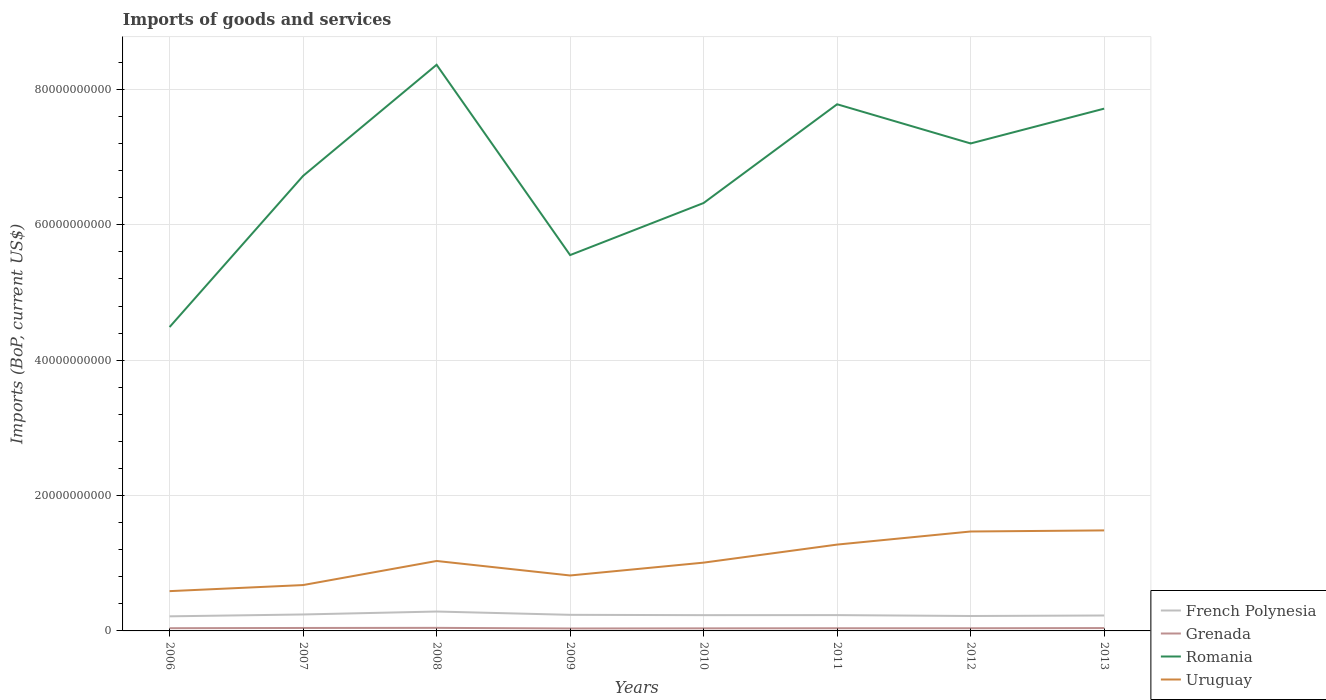How many different coloured lines are there?
Ensure brevity in your answer.  4. Does the line corresponding to Grenada intersect with the line corresponding to Romania?
Offer a very short reply. No. Across all years, what is the maximum amount spent on imports in Romania?
Offer a terse response. 4.49e+1. What is the total amount spent on imports in Grenada in the graph?
Your response must be concise. 4.14e+07. What is the difference between the highest and the second highest amount spent on imports in Romania?
Your response must be concise. 3.87e+1. What is the difference between the highest and the lowest amount spent on imports in French Polynesia?
Provide a short and direct response. 3. Is the amount spent on imports in Grenada strictly greater than the amount spent on imports in Uruguay over the years?
Keep it short and to the point. Yes. How many lines are there?
Your answer should be compact. 4. What is the difference between two consecutive major ticks on the Y-axis?
Give a very brief answer. 2.00e+1. Are the values on the major ticks of Y-axis written in scientific E-notation?
Your answer should be very brief. No. Does the graph contain grids?
Your answer should be very brief. Yes. How many legend labels are there?
Provide a succinct answer. 4. What is the title of the graph?
Your response must be concise. Imports of goods and services. Does "Senegal" appear as one of the legend labels in the graph?
Your answer should be very brief. No. What is the label or title of the X-axis?
Your answer should be compact. Years. What is the label or title of the Y-axis?
Keep it short and to the point. Imports (BoP, current US$). What is the Imports (BoP, current US$) of French Polynesia in 2006?
Offer a very short reply. 2.16e+09. What is the Imports (BoP, current US$) in Grenada in 2006?
Provide a short and direct response. 4.02e+08. What is the Imports (BoP, current US$) in Romania in 2006?
Offer a terse response. 4.49e+1. What is the Imports (BoP, current US$) of Uruguay in 2006?
Give a very brief answer. 5.88e+09. What is the Imports (BoP, current US$) in French Polynesia in 2007?
Make the answer very short. 2.43e+09. What is the Imports (BoP, current US$) in Grenada in 2007?
Your answer should be compact. 4.36e+08. What is the Imports (BoP, current US$) of Romania in 2007?
Offer a very short reply. 6.72e+1. What is the Imports (BoP, current US$) of Uruguay in 2007?
Ensure brevity in your answer.  6.78e+09. What is the Imports (BoP, current US$) in French Polynesia in 2008?
Provide a short and direct response. 2.87e+09. What is the Imports (BoP, current US$) in Grenada in 2008?
Your response must be concise. 4.52e+08. What is the Imports (BoP, current US$) in Romania in 2008?
Make the answer very short. 8.36e+1. What is the Imports (BoP, current US$) in Uruguay in 2008?
Offer a very short reply. 1.03e+1. What is the Imports (BoP, current US$) in French Polynesia in 2009?
Offer a very short reply. 2.38e+09. What is the Imports (BoP, current US$) in Grenada in 2009?
Ensure brevity in your answer.  3.61e+08. What is the Imports (BoP, current US$) of Romania in 2009?
Your answer should be compact. 5.55e+1. What is the Imports (BoP, current US$) of Uruguay in 2009?
Your response must be concise. 8.19e+09. What is the Imports (BoP, current US$) in French Polynesia in 2010?
Provide a short and direct response. 2.33e+09. What is the Imports (BoP, current US$) of Grenada in 2010?
Keep it short and to the point. 3.80e+08. What is the Imports (BoP, current US$) of Romania in 2010?
Give a very brief answer. 6.32e+1. What is the Imports (BoP, current US$) in Uruguay in 2010?
Give a very brief answer. 1.01e+1. What is the Imports (BoP, current US$) in French Polynesia in 2011?
Give a very brief answer. 2.34e+09. What is the Imports (BoP, current US$) of Grenada in 2011?
Offer a terse response. 3.95e+08. What is the Imports (BoP, current US$) in Romania in 2011?
Ensure brevity in your answer.  7.78e+1. What is the Imports (BoP, current US$) in Uruguay in 2011?
Ensure brevity in your answer.  1.28e+1. What is the Imports (BoP, current US$) of French Polynesia in 2012?
Keep it short and to the point. 2.20e+09. What is the Imports (BoP, current US$) in Grenada in 2012?
Your answer should be compact. 3.96e+08. What is the Imports (BoP, current US$) in Romania in 2012?
Keep it short and to the point. 7.20e+1. What is the Imports (BoP, current US$) of Uruguay in 2012?
Give a very brief answer. 1.47e+1. What is the Imports (BoP, current US$) of French Polynesia in 2013?
Keep it short and to the point. 2.28e+09. What is the Imports (BoP, current US$) in Grenada in 2013?
Keep it short and to the point. 4.23e+08. What is the Imports (BoP, current US$) of Romania in 2013?
Provide a succinct answer. 7.72e+1. What is the Imports (BoP, current US$) of Uruguay in 2013?
Give a very brief answer. 1.48e+1. Across all years, what is the maximum Imports (BoP, current US$) of French Polynesia?
Give a very brief answer. 2.87e+09. Across all years, what is the maximum Imports (BoP, current US$) of Grenada?
Ensure brevity in your answer.  4.52e+08. Across all years, what is the maximum Imports (BoP, current US$) of Romania?
Your answer should be compact. 8.36e+1. Across all years, what is the maximum Imports (BoP, current US$) in Uruguay?
Keep it short and to the point. 1.48e+1. Across all years, what is the minimum Imports (BoP, current US$) in French Polynesia?
Your answer should be very brief. 2.16e+09. Across all years, what is the minimum Imports (BoP, current US$) in Grenada?
Ensure brevity in your answer.  3.61e+08. Across all years, what is the minimum Imports (BoP, current US$) in Romania?
Provide a short and direct response. 4.49e+1. Across all years, what is the minimum Imports (BoP, current US$) in Uruguay?
Your answer should be compact. 5.88e+09. What is the total Imports (BoP, current US$) in French Polynesia in the graph?
Your response must be concise. 1.90e+1. What is the total Imports (BoP, current US$) in Grenada in the graph?
Offer a very short reply. 3.25e+09. What is the total Imports (BoP, current US$) in Romania in the graph?
Keep it short and to the point. 5.41e+11. What is the total Imports (BoP, current US$) in Uruguay in the graph?
Ensure brevity in your answer.  8.36e+1. What is the difference between the Imports (BoP, current US$) of French Polynesia in 2006 and that in 2007?
Offer a very short reply. -2.76e+08. What is the difference between the Imports (BoP, current US$) in Grenada in 2006 and that in 2007?
Your response must be concise. -3.40e+07. What is the difference between the Imports (BoP, current US$) of Romania in 2006 and that in 2007?
Keep it short and to the point. -2.23e+1. What is the difference between the Imports (BoP, current US$) of Uruguay in 2006 and that in 2007?
Offer a terse response. -8.98e+08. What is the difference between the Imports (BoP, current US$) of French Polynesia in 2006 and that in 2008?
Provide a short and direct response. -7.10e+08. What is the difference between the Imports (BoP, current US$) in Grenada in 2006 and that in 2008?
Your response must be concise. -4.93e+07. What is the difference between the Imports (BoP, current US$) of Romania in 2006 and that in 2008?
Give a very brief answer. -3.87e+1. What is the difference between the Imports (BoP, current US$) of Uruguay in 2006 and that in 2008?
Your answer should be very brief. -4.46e+09. What is the difference between the Imports (BoP, current US$) of French Polynesia in 2006 and that in 2009?
Your answer should be very brief. -2.22e+08. What is the difference between the Imports (BoP, current US$) of Grenada in 2006 and that in 2009?
Your answer should be very brief. 4.14e+07. What is the difference between the Imports (BoP, current US$) of Romania in 2006 and that in 2009?
Keep it short and to the point. -1.06e+1. What is the difference between the Imports (BoP, current US$) in Uruguay in 2006 and that in 2009?
Your answer should be very brief. -2.31e+09. What is the difference between the Imports (BoP, current US$) in French Polynesia in 2006 and that in 2010?
Your response must be concise. -1.75e+08. What is the difference between the Imports (BoP, current US$) in Grenada in 2006 and that in 2010?
Provide a succinct answer. 2.28e+07. What is the difference between the Imports (BoP, current US$) of Romania in 2006 and that in 2010?
Offer a very short reply. -1.83e+1. What is the difference between the Imports (BoP, current US$) of Uruguay in 2006 and that in 2010?
Offer a terse response. -4.21e+09. What is the difference between the Imports (BoP, current US$) in French Polynesia in 2006 and that in 2011?
Your response must be concise. -1.80e+08. What is the difference between the Imports (BoP, current US$) in Grenada in 2006 and that in 2011?
Your answer should be compact. 6.90e+06. What is the difference between the Imports (BoP, current US$) in Romania in 2006 and that in 2011?
Give a very brief answer. -3.29e+1. What is the difference between the Imports (BoP, current US$) in Uruguay in 2006 and that in 2011?
Keep it short and to the point. -6.88e+09. What is the difference between the Imports (BoP, current US$) of French Polynesia in 2006 and that in 2012?
Offer a very short reply. -4.88e+07. What is the difference between the Imports (BoP, current US$) of Grenada in 2006 and that in 2012?
Ensure brevity in your answer.  6.71e+06. What is the difference between the Imports (BoP, current US$) of Romania in 2006 and that in 2012?
Provide a short and direct response. -2.71e+1. What is the difference between the Imports (BoP, current US$) of Uruguay in 2006 and that in 2012?
Your response must be concise. -8.81e+09. What is the difference between the Imports (BoP, current US$) of French Polynesia in 2006 and that in 2013?
Provide a succinct answer. -1.23e+08. What is the difference between the Imports (BoP, current US$) in Grenada in 2006 and that in 2013?
Give a very brief answer. -2.08e+07. What is the difference between the Imports (BoP, current US$) of Romania in 2006 and that in 2013?
Your answer should be compact. -3.23e+1. What is the difference between the Imports (BoP, current US$) of Uruguay in 2006 and that in 2013?
Offer a terse response. -8.97e+09. What is the difference between the Imports (BoP, current US$) in French Polynesia in 2007 and that in 2008?
Ensure brevity in your answer.  -4.33e+08. What is the difference between the Imports (BoP, current US$) of Grenada in 2007 and that in 2008?
Give a very brief answer. -1.53e+07. What is the difference between the Imports (BoP, current US$) of Romania in 2007 and that in 2008?
Provide a succinct answer. -1.64e+1. What is the difference between the Imports (BoP, current US$) of Uruguay in 2007 and that in 2008?
Provide a short and direct response. -3.56e+09. What is the difference between the Imports (BoP, current US$) of French Polynesia in 2007 and that in 2009?
Offer a very short reply. 5.44e+07. What is the difference between the Imports (BoP, current US$) of Grenada in 2007 and that in 2009?
Provide a succinct answer. 7.54e+07. What is the difference between the Imports (BoP, current US$) in Romania in 2007 and that in 2009?
Your answer should be compact. 1.17e+1. What is the difference between the Imports (BoP, current US$) in Uruguay in 2007 and that in 2009?
Provide a succinct answer. -1.41e+09. What is the difference between the Imports (BoP, current US$) of French Polynesia in 2007 and that in 2010?
Your answer should be very brief. 1.02e+08. What is the difference between the Imports (BoP, current US$) of Grenada in 2007 and that in 2010?
Offer a very short reply. 5.68e+07. What is the difference between the Imports (BoP, current US$) in Romania in 2007 and that in 2010?
Provide a short and direct response. 4.01e+09. What is the difference between the Imports (BoP, current US$) in Uruguay in 2007 and that in 2010?
Your answer should be compact. -3.31e+09. What is the difference between the Imports (BoP, current US$) in French Polynesia in 2007 and that in 2011?
Ensure brevity in your answer.  9.64e+07. What is the difference between the Imports (BoP, current US$) of Grenada in 2007 and that in 2011?
Make the answer very short. 4.09e+07. What is the difference between the Imports (BoP, current US$) of Romania in 2007 and that in 2011?
Provide a short and direct response. -1.06e+1. What is the difference between the Imports (BoP, current US$) in Uruguay in 2007 and that in 2011?
Give a very brief answer. -5.98e+09. What is the difference between the Imports (BoP, current US$) in French Polynesia in 2007 and that in 2012?
Your response must be concise. 2.27e+08. What is the difference between the Imports (BoP, current US$) of Grenada in 2007 and that in 2012?
Keep it short and to the point. 4.07e+07. What is the difference between the Imports (BoP, current US$) of Romania in 2007 and that in 2012?
Ensure brevity in your answer.  -4.79e+09. What is the difference between the Imports (BoP, current US$) of Uruguay in 2007 and that in 2012?
Offer a very short reply. -7.91e+09. What is the difference between the Imports (BoP, current US$) in French Polynesia in 2007 and that in 2013?
Make the answer very short. 1.53e+08. What is the difference between the Imports (BoP, current US$) of Grenada in 2007 and that in 2013?
Provide a short and direct response. 1.32e+07. What is the difference between the Imports (BoP, current US$) in Romania in 2007 and that in 2013?
Your response must be concise. -9.93e+09. What is the difference between the Imports (BoP, current US$) of Uruguay in 2007 and that in 2013?
Give a very brief answer. -8.07e+09. What is the difference between the Imports (BoP, current US$) of French Polynesia in 2008 and that in 2009?
Make the answer very short. 4.88e+08. What is the difference between the Imports (BoP, current US$) of Grenada in 2008 and that in 2009?
Your response must be concise. 9.08e+07. What is the difference between the Imports (BoP, current US$) of Romania in 2008 and that in 2009?
Provide a succinct answer. 2.81e+1. What is the difference between the Imports (BoP, current US$) of Uruguay in 2008 and that in 2009?
Your answer should be compact. 2.14e+09. What is the difference between the Imports (BoP, current US$) of French Polynesia in 2008 and that in 2010?
Keep it short and to the point. 5.35e+08. What is the difference between the Imports (BoP, current US$) in Grenada in 2008 and that in 2010?
Keep it short and to the point. 7.22e+07. What is the difference between the Imports (BoP, current US$) of Romania in 2008 and that in 2010?
Your answer should be very brief. 2.04e+1. What is the difference between the Imports (BoP, current US$) in Uruguay in 2008 and that in 2010?
Keep it short and to the point. 2.44e+08. What is the difference between the Imports (BoP, current US$) in French Polynesia in 2008 and that in 2011?
Your response must be concise. 5.30e+08. What is the difference between the Imports (BoP, current US$) in Grenada in 2008 and that in 2011?
Offer a terse response. 5.62e+07. What is the difference between the Imports (BoP, current US$) in Romania in 2008 and that in 2011?
Keep it short and to the point. 5.84e+09. What is the difference between the Imports (BoP, current US$) in Uruguay in 2008 and that in 2011?
Offer a terse response. -2.42e+09. What is the difference between the Imports (BoP, current US$) in French Polynesia in 2008 and that in 2012?
Provide a short and direct response. 6.61e+08. What is the difference between the Imports (BoP, current US$) in Grenada in 2008 and that in 2012?
Provide a succinct answer. 5.60e+07. What is the difference between the Imports (BoP, current US$) in Romania in 2008 and that in 2012?
Ensure brevity in your answer.  1.16e+1. What is the difference between the Imports (BoP, current US$) of Uruguay in 2008 and that in 2012?
Your answer should be compact. -4.36e+09. What is the difference between the Imports (BoP, current US$) in French Polynesia in 2008 and that in 2013?
Your answer should be compact. 5.86e+08. What is the difference between the Imports (BoP, current US$) in Grenada in 2008 and that in 2013?
Your response must be concise. 2.85e+07. What is the difference between the Imports (BoP, current US$) in Romania in 2008 and that in 2013?
Your answer should be very brief. 6.48e+09. What is the difference between the Imports (BoP, current US$) of Uruguay in 2008 and that in 2013?
Your answer should be very brief. -4.52e+09. What is the difference between the Imports (BoP, current US$) of French Polynesia in 2009 and that in 2010?
Offer a terse response. 4.72e+07. What is the difference between the Imports (BoP, current US$) in Grenada in 2009 and that in 2010?
Your answer should be very brief. -1.86e+07. What is the difference between the Imports (BoP, current US$) in Romania in 2009 and that in 2010?
Offer a very short reply. -7.69e+09. What is the difference between the Imports (BoP, current US$) in Uruguay in 2009 and that in 2010?
Your answer should be compact. -1.90e+09. What is the difference between the Imports (BoP, current US$) in French Polynesia in 2009 and that in 2011?
Provide a succinct answer. 4.20e+07. What is the difference between the Imports (BoP, current US$) of Grenada in 2009 and that in 2011?
Make the answer very short. -3.45e+07. What is the difference between the Imports (BoP, current US$) in Romania in 2009 and that in 2011?
Give a very brief answer. -2.23e+1. What is the difference between the Imports (BoP, current US$) of Uruguay in 2009 and that in 2011?
Give a very brief answer. -4.56e+09. What is the difference between the Imports (BoP, current US$) of French Polynesia in 2009 and that in 2012?
Keep it short and to the point. 1.73e+08. What is the difference between the Imports (BoP, current US$) of Grenada in 2009 and that in 2012?
Offer a very short reply. -3.47e+07. What is the difference between the Imports (BoP, current US$) of Romania in 2009 and that in 2012?
Your answer should be compact. -1.65e+1. What is the difference between the Imports (BoP, current US$) in Uruguay in 2009 and that in 2012?
Make the answer very short. -6.50e+09. What is the difference between the Imports (BoP, current US$) in French Polynesia in 2009 and that in 2013?
Offer a very short reply. 9.83e+07. What is the difference between the Imports (BoP, current US$) of Grenada in 2009 and that in 2013?
Make the answer very short. -6.23e+07. What is the difference between the Imports (BoP, current US$) of Romania in 2009 and that in 2013?
Give a very brief answer. -2.16e+1. What is the difference between the Imports (BoP, current US$) in Uruguay in 2009 and that in 2013?
Keep it short and to the point. -6.66e+09. What is the difference between the Imports (BoP, current US$) of French Polynesia in 2010 and that in 2011?
Provide a short and direct response. -5.19e+06. What is the difference between the Imports (BoP, current US$) of Grenada in 2010 and that in 2011?
Your answer should be very brief. -1.59e+07. What is the difference between the Imports (BoP, current US$) of Romania in 2010 and that in 2011?
Keep it short and to the point. -1.46e+1. What is the difference between the Imports (BoP, current US$) in Uruguay in 2010 and that in 2011?
Your answer should be compact. -2.67e+09. What is the difference between the Imports (BoP, current US$) of French Polynesia in 2010 and that in 2012?
Give a very brief answer. 1.26e+08. What is the difference between the Imports (BoP, current US$) in Grenada in 2010 and that in 2012?
Give a very brief answer. -1.61e+07. What is the difference between the Imports (BoP, current US$) of Romania in 2010 and that in 2012?
Ensure brevity in your answer.  -8.80e+09. What is the difference between the Imports (BoP, current US$) in Uruguay in 2010 and that in 2012?
Offer a very short reply. -4.60e+09. What is the difference between the Imports (BoP, current US$) in French Polynesia in 2010 and that in 2013?
Your answer should be very brief. 5.12e+07. What is the difference between the Imports (BoP, current US$) of Grenada in 2010 and that in 2013?
Offer a very short reply. -4.37e+07. What is the difference between the Imports (BoP, current US$) of Romania in 2010 and that in 2013?
Make the answer very short. -1.39e+1. What is the difference between the Imports (BoP, current US$) of Uruguay in 2010 and that in 2013?
Offer a very short reply. -4.76e+09. What is the difference between the Imports (BoP, current US$) in French Polynesia in 2011 and that in 2012?
Provide a succinct answer. 1.31e+08. What is the difference between the Imports (BoP, current US$) of Grenada in 2011 and that in 2012?
Make the answer very short. -1.89e+05. What is the difference between the Imports (BoP, current US$) of Romania in 2011 and that in 2012?
Make the answer very short. 5.79e+09. What is the difference between the Imports (BoP, current US$) in Uruguay in 2011 and that in 2012?
Keep it short and to the point. -1.93e+09. What is the difference between the Imports (BoP, current US$) in French Polynesia in 2011 and that in 2013?
Your answer should be very brief. 5.64e+07. What is the difference between the Imports (BoP, current US$) of Grenada in 2011 and that in 2013?
Keep it short and to the point. -2.77e+07. What is the difference between the Imports (BoP, current US$) in Romania in 2011 and that in 2013?
Your response must be concise. 6.46e+08. What is the difference between the Imports (BoP, current US$) of Uruguay in 2011 and that in 2013?
Your response must be concise. -2.09e+09. What is the difference between the Imports (BoP, current US$) of French Polynesia in 2012 and that in 2013?
Your answer should be very brief. -7.46e+07. What is the difference between the Imports (BoP, current US$) in Grenada in 2012 and that in 2013?
Offer a terse response. -2.76e+07. What is the difference between the Imports (BoP, current US$) of Romania in 2012 and that in 2013?
Offer a very short reply. -5.14e+09. What is the difference between the Imports (BoP, current US$) of Uruguay in 2012 and that in 2013?
Your response must be concise. -1.60e+08. What is the difference between the Imports (BoP, current US$) of French Polynesia in 2006 and the Imports (BoP, current US$) of Grenada in 2007?
Provide a short and direct response. 1.72e+09. What is the difference between the Imports (BoP, current US$) in French Polynesia in 2006 and the Imports (BoP, current US$) in Romania in 2007?
Provide a succinct answer. -6.51e+1. What is the difference between the Imports (BoP, current US$) of French Polynesia in 2006 and the Imports (BoP, current US$) of Uruguay in 2007?
Give a very brief answer. -4.62e+09. What is the difference between the Imports (BoP, current US$) in Grenada in 2006 and the Imports (BoP, current US$) in Romania in 2007?
Offer a terse response. -6.68e+1. What is the difference between the Imports (BoP, current US$) in Grenada in 2006 and the Imports (BoP, current US$) in Uruguay in 2007?
Provide a short and direct response. -6.37e+09. What is the difference between the Imports (BoP, current US$) in Romania in 2006 and the Imports (BoP, current US$) in Uruguay in 2007?
Give a very brief answer. 3.81e+1. What is the difference between the Imports (BoP, current US$) of French Polynesia in 2006 and the Imports (BoP, current US$) of Grenada in 2008?
Your response must be concise. 1.70e+09. What is the difference between the Imports (BoP, current US$) in French Polynesia in 2006 and the Imports (BoP, current US$) in Romania in 2008?
Give a very brief answer. -8.15e+1. What is the difference between the Imports (BoP, current US$) of French Polynesia in 2006 and the Imports (BoP, current US$) of Uruguay in 2008?
Give a very brief answer. -8.18e+09. What is the difference between the Imports (BoP, current US$) in Grenada in 2006 and the Imports (BoP, current US$) in Romania in 2008?
Provide a succinct answer. -8.32e+1. What is the difference between the Imports (BoP, current US$) of Grenada in 2006 and the Imports (BoP, current US$) of Uruguay in 2008?
Keep it short and to the point. -9.93e+09. What is the difference between the Imports (BoP, current US$) of Romania in 2006 and the Imports (BoP, current US$) of Uruguay in 2008?
Make the answer very short. 3.46e+1. What is the difference between the Imports (BoP, current US$) of French Polynesia in 2006 and the Imports (BoP, current US$) of Grenada in 2009?
Make the answer very short. 1.79e+09. What is the difference between the Imports (BoP, current US$) of French Polynesia in 2006 and the Imports (BoP, current US$) of Romania in 2009?
Provide a succinct answer. -5.34e+1. What is the difference between the Imports (BoP, current US$) in French Polynesia in 2006 and the Imports (BoP, current US$) in Uruguay in 2009?
Offer a terse response. -6.03e+09. What is the difference between the Imports (BoP, current US$) in Grenada in 2006 and the Imports (BoP, current US$) in Romania in 2009?
Provide a short and direct response. -5.51e+1. What is the difference between the Imports (BoP, current US$) in Grenada in 2006 and the Imports (BoP, current US$) in Uruguay in 2009?
Your answer should be very brief. -7.79e+09. What is the difference between the Imports (BoP, current US$) of Romania in 2006 and the Imports (BoP, current US$) of Uruguay in 2009?
Ensure brevity in your answer.  3.67e+1. What is the difference between the Imports (BoP, current US$) of French Polynesia in 2006 and the Imports (BoP, current US$) of Grenada in 2010?
Provide a succinct answer. 1.78e+09. What is the difference between the Imports (BoP, current US$) of French Polynesia in 2006 and the Imports (BoP, current US$) of Romania in 2010?
Give a very brief answer. -6.11e+1. What is the difference between the Imports (BoP, current US$) of French Polynesia in 2006 and the Imports (BoP, current US$) of Uruguay in 2010?
Ensure brevity in your answer.  -7.93e+09. What is the difference between the Imports (BoP, current US$) of Grenada in 2006 and the Imports (BoP, current US$) of Romania in 2010?
Offer a very short reply. -6.28e+1. What is the difference between the Imports (BoP, current US$) in Grenada in 2006 and the Imports (BoP, current US$) in Uruguay in 2010?
Provide a short and direct response. -9.69e+09. What is the difference between the Imports (BoP, current US$) in Romania in 2006 and the Imports (BoP, current US$) in Uruguay in 2010?
Ensure brevity in your answer.  3.48e+1. What is the difference between the Imports (BoP, current US$) in French Polynesia in 2006 and the Imports (BoP, current US$) in Grenada in 2011?
Offer a terse response. 1.76e+09. What is the difference between the Imports (BoP, current US$) in French Polynesia in 2006 and the Imports (BoP, current US$) in Romania in 2011?
Provide a short and direct response. -7.56e+1. What is the difference between the Imports (BoP, current US$) in French Polynesia in 2006 and the Imports (BoP, current US$) in Uruguay in 2011?
Offer a terse response. -1.06e+1. What is the difference between the Imports (BoP, current US$) in Grenada in 2006 and the Imports (BoP, current US$) in Romania in 2011?
Your answer should be very brief. -7.74e+1. What is the difference between the Imports (BoP, current US$) of Grenada in 2006 and the Imports (BoP, current US$) of Uruguay in 2011?
Provide a short and direct response. -1.24e+1. What is the difference between the Imports (BoP, current US$) in Romania in 2006 and the Imports (BoP, current US$) in Uruguay in 2011?
Make the answer very short. 3.21e+1. What is the difference between the Imports (BoP, current US$) of French Polynesia in 2006 and the Imports (BoP, current US$) of Grenada in 2012?
Your response must be concise. 1.76e+09. What is the difference between the Imports (BoP, current US$) in French Polynesia in 2006 and the Imports (BoP, current US$) in Romania in 2012?
Give a very brief answer. -6.99e+1. What is the difference between the Imports (BoP, current US$) of French Polynesia in 2006 and the Imports (BoP, current US$) of Uruguay in 2012?
Your answer should be compact. -1.25e+1. What is the difference between the Imports (BoP, current US$) of Grenada in 2006 and the Imports (BoP, current US$) of Romania in 2012?
Offer a very short reply. -7.16e+1. What is the difference between the Imports (BoP, current US$) of Grenada in 2006 and the Imports (BoP, current US$) of Uruguay in 2012?
Make the answer very short. -1.43e+1. What is the difference between the Imports (BoP, current US$) of Romania in 2006 and the Imports (BoP, current US$) of Uruguay in 2012?
Make the answer very short. 3.02e+1. What is the difference between the Imports (BoP, current US$) of French Polynesia in 2006 and the Imports (BoP, current US$) of Grenada in 2013?
Keep it short and to the point. 1.73e+09. What is the difference between the Imports (BoP, current US$) of French Polynesia in 2006 and the Imports (BoP, current US$) of Romania in 2013?
Provide a succinct answer. -7.50e+1. What is the difference between the Imports (BoP, current US$) in French Polynesia in 2006 and the Imports (BoP, current US$) in Uruguay in 2013?
Provide a short and direct response. -1.27e+1. What is the difference between the Imports (BoP, current US$) in Grenada in 2006 and the Imports (BoP, current US$) in Romania in 2013?
Ensure brevity in your answer.  -7.68e+1. What is the difference between the Imports (BoP, current US$) in Grenada in 2006 and the Imports (BoP, current US$) in Uruguay in 2013?
Offer a terse response. -1.44e+1. What is the difference between the Imports (BoP, current US$) of Romania in 2006 and the Imports (BoP, current US$) of Uruguay in 2013?
Give a very brief answer. 3.00e+1. What is the difference between the Imports (BoP, current US$) of French Polynesia in 2007 and the Imports (BoP, current US$) of Grenada in 2008?
Give a very brief answer. 1.98e+09. What is the difference between the Imports (BoP, current US$) in French Polynesia in 2007 and the Imports (BoP, current US$) in Romania in 2008?
Make the answer very short. -8.12e+1. What is the difference between the Imports (BoP, current US$) in French Polynesia in 2007 and the Imports (BoP, current US$) in Uruguay in 2008?
Offer a terse response. -7.90e+09. What is the difference between the Imports (BoP, current US$) of Grenada in 2007 and the Imports (BoP, current US$) of Romania in 2008?
Keep it short and to the point. -8.32e+1. What is the difference between the Imports (BoP, current US$) in Grenada in 2007 and the Imports (BoP, current US$) in Uruguay in 2008?
Offer a terse response. -9.90e+09. What is the difference between the Imports (BoP, current US$) of Romania in 2007 and the Imports (BoP, current US$) of Uruguay in 2008?
Keep it short and to the point. 5.69e+1. What is the difference between the Imports (BoP, current US$) of French Polynesia in 2007 and the Imports (BoP, current US$) of Grenada in 2009?
Offer a very short reply. 2.07e+09. What is the difference between the Imports (BoP, current US$) in French Polynesia in 2007 and the Imports (BoP, current US$) in Romania in 2009?
Provide a short and direct response. -5.31e+1. What is the difference between the Imports (BoP, current US$) of French Polynesia in 2007 and the Imports (BoP, current US$) of Uruguay in 2009?
Your answer should be very brief. -5.76e+09. What is the difference between the Imports (BoP, current US$) in Grenada in 2007 and the Imports (BoP, current US$) in Romania in 2009?
Your answer should be compact. -5.51e+1. What is the difference between the Imports (BoP, current US$) in Grenada in 2007 and the Imports (BoP, current US$) in Uruguay in 2009?
Ensure brevity in your answer.  -7.75e+09. What is the difference between the Imports (BoP, current US$) of Romania in 2007 and the Imports (BoP, current US$) of Uruguay in 2009?
Your answer should be very brief. 5.90e+1. What is the difference between the Imports (BoP, current US$) in French Polynesia in 2007 and the Imports (BoP, current US$) in Grenada in 2010?
Your answer should be compact. 2.05e+09. What is the difference between the Imports (BoP, current US$) in French Polynesia in 2007 and the Imports (BoP, current US$) in Romania in 2010?
Offer a very short reply. -6.08e+1. What is the difference between the Imports (BoP, current US$) in French Polynesia in 2007 and the Imports (BoP, current US$) in Uruguay in 2010?
Give a very brief answer. -7.66e+09. What is the difference between the Imports (BoP, current US$) in Grenada in 2007 and the Imports (BoP, current US$) in Romania in 2010?
Your response must be concise. -6.28e+1. What is the difference between the Imports (BoP, current US$) of Grenada in 2007 and the Imports (BoP, current US$) of Uruguay in 2010?
Your response must be concise. -9.65e+09. What is the difference between the Imports (BoP, current US$) in Romania in 2007 and the Imports (BoP, current US$) in Uruguay in 2010?
Your answer should be compact. 5.71e+1. What is the difference between the Imports (BoP, current US$) in French Polynesia in 2007 and the Imports (BoP, current US$) in Grenada in 2011?
Make the answer very short. 2.04e+09. What is the difference between the Imports (BoP, current US$) of French Polynesia in 2007 and the Imports (BoP, current US$) of Romania in 2011?
Your answer should be compact. -7.54e+1. What is the difference between the Imports (BoP, current US$) in French Polynesia in 2007 and the Imports (BoP, current US$) in Uruguay in 2011?
Your answer should be very brief. -1.03e+1. What is the difference between the Imports (BoP, current US$) of Grenada in 2007 and the Imports (BoP, current US$) of Romania in 2011?
Make the answer very short. -7.74e+1. What is the difference between the Imports (BoP, current US$) in Grenada in 2007 and the Imports (BoP, current US$) in Uruguay in 2011?
Offer a terse response. -1.23e+1. What is the difference between the Imports (BoP, current US$) of Romania in 2007 and the Imports (BoP, current US$) of Uruguay in 2011?
Ensure brevity in your answer.  5.45e+1. What is the difference between the Imports (BoP, current US$) in French Polynesia in 2007 and the Imports (BoP, current US$) in Grenada in 2012?
Your answer should be very brief. 2.04e+09. What is the difference between the Imports (BoP, current US$) of French Polynesia in 2007 and the Imports (BoP, current US$) of Romania in 2012?
Your response must be concise. -6.96e+1. What is the difference between the Imports (BoP, current US$) of French Polynesia in 2007 and the Imports (BoP, current US$) of Uruguay in 2012?
Give a very brief answer. -1.23e+1. What is the difference between the Imports (BoP, current US$) in Grenada in 2007 and the Imports (BoP, current US$) in Romania in 2012?
Keep it short and to the point. -7.16e+1. What is the difference between the Imports (BoP, current US$) in Grenada in 2007 and the Imports (BoP, current US$) in Uruguay in 2012?
Your response must be concise. -1.43e+1. What is the difference between the Imports (BoP, current US$) of Romania in 2007 and the Imports (BoP, current US$) of Uruguay in 2012?
Your answer should be very brief. 5.25e+1. What is the difference between the Imports (BoP, current US$) in French Polynesia in 2007 and the Imports (BoP, current US$) in Grenada in 2013?
Offer a terse response. 2.01e+09. What is the difference between the Imports (BoP, current US$) in French Polynesia in 2007 and the Imports (BoP, current US$) in Romania in 2013?
Offer a very short reply. -7.47e+1. What is the difference between the Imports (BoP, current US$) in French Polynesia in 2007 and the Imports (BoP, current US$) in Uruguay in 2013?
Ensure brevity in your answer.  -1.24e+1. What is the difference between the Imports (BoP, current US$) in Grenada in 2007 and the Imports (BoP, current US$) in Romania in 2013?
Give a very brief answer. -7.67e+1. What is the difference between the Imports (BoP, current US$) in Grenada in 2007 and the Imports (BoP, current US$) in Uruguay in 2013?
Provide a succinct answer. -1.44e+1. What is the difference between the Imports (BoP, current US$) in Romania in 2007 and the Imports (BoP, current US$) in Uruguay in 2013?
Offer a very short reply. 5.24e+1. What is the difference between the Imports (BoP, current US$) of French Polynesia in 2008 and the Imports (BoP, current US$) of Grenada in 2009?
Your answer should be very brief. 2.50e+09. What is the difference between the Imports (BoP, current US$) in French Polynesia in 2008 and the Imports (BoP, current US$) in Romania in 2009?
Ensure brevity in your answer.  -5.27e+1. What is the difference between the Imports (BoP, current US$) in French Polynesia in 2008 and the Imports (BoP, current US$) in Uruguay in 2009?
Keep it short and to the point. -5.33e+09. What is the difference between the Imports (BoP, current US$) of Grenada in 2008 and the Imports (BoP, current US$) of Romania in 2009?
Keep it short and to the point. -5.51e+1. What is the difference between the Imports (BoP, current US$) in Grenada in 2008 and the Imports (BoP, current US$) in Uruguay in 2009?
Offer a very short reply. -7.74e+09. What is the difference between the Imports (BoP, current US$) in Romania in 2008 and the Imports (BoP, current US$) in Uruguay in 2009?
Make the answer very short. 7.55e+1. What is the difference between the Imports (BoP, current US$) of French Polynesia in 2008 and the Imports (BoP, current US$) of Grenada in 2010?
Your response must be concise. 2.49e+09. What is the difference between the Imports (BoP, current US$) in French Polynesia in 2008 and the Imports (BoP, current US$) in Romania in 2010?
Your answer should be very brief. -6.04e+1. What is the difference between the Imports (BoP, current US$) in French Polynesia in 2008 and the Imports (BoP, current US$) in Uruguay in 2010?
Your answer should be compact. -7.22e+09. What is the difference between the Imports (BoP, current US$) in Grenada in 2008 and the Imports (BoP, current US$) in Romania in 2010?
Give a very brief answer. -6.28e+1. What is the difference between the Imports (BoP, current US$) in Grenada in 2008 and the Imports (BoP, current US$) in Uruguay in 2010?
Provide a short and direct response. -9.64e+09. What is the difference between the Imports (BoP, current US$) in Romania in 2008 and the Imports (BoP, current US$) in Uruguay in 2010?
Your response must be concise. 7.36e+1. What is the difference between the Imports (BoP, current US$) of French Polynesia in 2008 and the Imports (BoP, current US$) of Grenada in 2011?
Your response must be concise. 2.47e+09. What is the difference between the Imports (BoP, current US$) in French Polynesia in 2008 and the Imports (BoP, current US$) in Romania in 2011?
Your response must be concise. -7.49e+1. What is the difference between the Imports (BoP, current US$) of French Polynesia in 2008 and the Imports (BoP, current US$) of Uruguay in 2011?
Provide a short and direct response. -9.89e+09. What is the difference between the Imports (BoP, current US$) in Grenada in 2008 and the Imports (BoP, current US$) in Romania in 2011?
Your response must be concise. -7.74e+1. What is the difference between the Imports (BoP, current US$) in Grenada in 2008 and the Imports (BoP, current US$) in Uruguay in 2011?
Your response must be concise. -1.23e+1. What is the difference between the Imports (BoP, current US$) in Romania in 2008 and the Imports (BoP, current US$) in Uruguay in 2011?
Provide a succinct answer. 7.09e+1. What is the difference between the Imports (BoP, current US$) of French Polynesia in 2008 and the Imports (BoP, current US$) of Grenada in 2012?
Your answer should be very brief. 2.47e+09. What is the difference between the Imports (BoP, current US$) in French Polynesia in 2008 and the Imports (BoP, current US$) in Romania in 2012?
Offer a very short reply. -6.91e+1. What is the difference between the Imports (BoP, current US$) in French Polynesia in 2008 and the Imports (BoP, current US$) in Uruguay in 2012?
Offer a terse response. -1.18e+1. What is the difference between the Imports (BoP, current US$) in Grenada in 2008 and the Imports (BoP, current US$) in Romania in 2012?
Provide a short and direct response. -7.16e+1. What is the difference between the Imports (BoP, current US$) in Grenada in 2008 and the Imports (BoP, current US$) in Uruguay in 2012?
Your response must be concise. -1.42e+1. What is the difference between the Imports (BoP, current US$) in Romania in 2008 and the Imports (BoP, current US$) in Uruguay in 2012?
Ensure brevity in your answer.  6.90e+1. What is the difference between the Imports (BoP, current US$) in French Polynesia in 2008 and the Imports (BoP, current US$) in Grenada in 2013?
Keep it short and to the point. 2.44e+09. What is the difference between the Imports (BoP, current US$) in French Polynesia in 2008 and the Imports (BoP, current US$) in Romania in 2013?
Offer a very short reply. -7.43e+1. What is the difference between the Imports (BoP, current US$) of French Polynesia in 2008 and the Imports (BoP, current US$) of Uruguay in 2013?
Provide a succinct answer. -1.20e+1. What is the difference between the Imports (BoP, current US$) of Grenada in 2008 and the Imports (BoP, current US$) of Romania in 2013?
Provide a short and direct response. -7.67e+1. What is the difference between the Imports (BoP, current US$) of Grenada in 2008 and the Imports (BoP, current US$) of Uruguay in 2013?
Provide a short and direct response. -1.44e+1. What is the difference between the Imports (BoP, current US$) in Romania in 2008 and the Imports (BoP, current US$) in Uruguay in 2013?
Keep it short and to the point. 6.88e+1. What is the difference between the Imports (BoP, current US$) of French Polynesia in 2009 and the Imports (BoP, current US$) of Grenada in 2010?
Make the answer very short. 2.00e+09. What is the difference between the Imports (BoP, current US$) in French Polynesia in 2009 and the Imports (BoP, current US$) in Romania in 2010?
Keep it short and to the point. -6.08e+1. What is the difference between the Imports (BoP, current US$) of French Polynesia in 2009 and the Imports (BoP, current US$) of Uruguay in 2010?
Provide a short and direct response. -7.71e+09. What is the difference between the Imports (BoP, current US$) of Grenada in 2009 and the Imports (BoP, current US$) of Romania in 2010?
Make the answer very short. -6.29e+1. What is the difference between the Imports (BoP, current US$) in Grenada in 2009 and the Imports (BoP, current US$) in Uruguay in 2010?
Your answer should be very brief. -9.73e+09. What is the difference between the Imports (BoP, current US$) of Romania in 2009 and the Imports (BoP, current US$) of Uruguay in 2010?
Offer a terse response. 4.54e+1. What is the difference between the Imports (BoP, current US$) in French Polynesia in 2009 and the Imports (BoP, current US$) in Grenada in 2011?
Your answer should be compact. 1.98e+09. What is the difference between the Imports (BoP, current US$) in French Polynesia in 2009 and the Imports (BoP, current US$) in Romania in 2011?
Offer a very short reply. -7.54e+1. What is the difference between the Imports (BoP, current US$) of French Polynesia in 2009 and the Imports (BoP, current US$) of Uruguay in 2011?
Your answer should be very brief. -1.04e+1. What is the difference between the Imports (BoP, current US$) of Grenada in 2009 and the Imports (BoP, current US$) of Romania in 2011?
Your answer should be very brief. -7.74e+1. What is the difference between the Imports (BoP, current US$) in Grenada in 2009 and the Imports (BoP, current US$) in Uruguay in 2011?
Your answer should be very brief. -1.24e+1. What is the difference between the Imports (BoP, current US$) of Romania in 2009 and the Imports (BoP, current US$) of Uruguay in 2011?
Make the answer very short. 4.28e+1. What is the difference between the Imports (BoP, current US$) in French Polynesia in 2009 and the Imports (BoP, current US$) in Grenada in 2012?
Make the answer very short. 1.98e+09. What is the difference between the Imports (BoP, current US$) in French Polynesia in 2009 and the Imports (BoP, current US$) in Romania in 2012?
Ensure brevity in your answer.  -6.96e+1. What is the difference between the Imports (BoP, current US$) of French Polynesia in 2009 and the Imports (BoP, current US$) of Uruguay in 2012?
Your response must be concise. -1.23e+1. What is the difference between the Imports (BoP, current US$) of Grenada in 2009 and the Imports (BoP, current US$) of Romania in 2012?
Offer a terse response. -7.17e+1. What is the difference between the Imports (BoP, current US$) of Grenada in 2009 and the Imports (BoP, current US$) of Uruguay in 2012?
Ensure brevity in your answer.  -1.43e+1. What is the difference between the Imports (BoP, current US$) in Romania in 2009 and the Imports (BoP, current US$) in Uruguay in 2012?
Offer a very short reply. 4.08e+1. What is the difference between the Imports (BoP, current US$) in French Polynesia in 2009 and the Imports (BoP, current US$) in Grenada in 2013?
Give a very brief answer. 1.95e+09. What is the difference between the Imports (BoP, current US$) in French Polynesia in 2009 and the Imports (BoP, current US$) in Romania in 2013?
Your answer should be compact. -7.48e+1. What is the difference between the Imports (BoP, current US$) in French Polynesia in 2009 and the Imports (BoP, current US$) in Uruguay in 2013?
Your response must be concise. -1.25e+1. What is the difference between the Imports (BoP, current US$) of Grenada in 2009 and the Imports (BoP, current US$) of Romania in 2013?
Your answer should be very brief. -7.68e+1. What is the difference between the Imports (BoP, current US$) in Grenada in 2009 and the Imports (BoP, current US$) in Uruguay in 2013?
Provide a short and direct response. -1.45e+1. What is the difference between the Imports (BoP, current US$) of Romania in 2009 and the Imports (BoP, current US$) of Uruguay in 2013?
Offer a terse response. 4.07e+1. What is the difference between the Imports (BoP, current US$) in French Polynesia in 2010 and the Imports (BoP, current US$) in Grenada in 2011?
Provide a succinct answer. 1.93e+09. What is the difference between the Imports (BoP, current US$) in French Polynesia in 2010 and the Imports (BoP, current US$) in Romania in 2011?
Provide a succinct answer. -7.55e+1. What is the difference between the Imports (BoP, current US$) in French Polynesia in 2010 and the Imports (BoP, current US$) in Uruguay in 2011?
Make the answer very short. -1.04e+1. What is the difference between the Imports (BoP, current US$) of Grenada in 2010 and the Imports (BoP, current US$) of Romania in 2011?
Make the answer very short. -7.74e+1. What is the difference between the Imports (BoP, current US$) in Grenada in 2010 and the Imports (BoP, current US$) in Uruguay in 2011?
Your answer should be very brief. -1.24e+1. What is the difference between the Imports (BoP, current US$) of Romania in 2010 and the Imports (BoP, current US$) of Uruguay in 2011?
Make the answer very short. 5.05e+1. What is the difference between the Imports (BoP, current US$) of French Polynesia in 2010 and the Imports (BoP, current US$) of Grenada in 2012?
Give a very brief answer. 1.93e+09. What is the difference between the Imports (BoP, current US$) of French Polynesia in 2010 and the Imports (BoP, current US$) of Romania in 2012?
Your answer should be compact. -6.97e+1. What is the difference between the Imports (BoP, current US$) in French Polynesia in 2010 and the Imports (BoP, current US$) in Uruguay in 2012?
Ensure brevity in your answer.  -1.24e+1. What is the difference between the Imports (BoP, current US$) of Grenada in 2010 and the Imports (BoP, current US$) of Romania in 2012?
Provide a succinct answer. -7.16e+1. What is the difference between the Imports (BoP, current US$) of Grenada in 2010 and the Imports (BoP, current US$) of Uruguay in 2012?
Your response must be concise. -1.43e+1. What is the difference between the Imports (BoP, current US$) of Romania in 2010 and the Imports (BoP, current US$) of Uruguay in 2012?
Give a very brief answer. 4.85e+1. What is the difference between the Imports (BoP, current US$) in French Polynesia in 2010 and the Imports (BoP, current US$) in Grenada in 2013?
Your response must be concise. 1.91e+09. What is the difference between the Imports (BoP, current US$) of French Polynesia in 2010 and the Imports (BoP, current US$) of Romania in 2013?
Give a very brief answer. -7.48e+1. What is the difference between the Imports (BoP, current US$) in French Polynesia in 2010 and the Imports (BoP, current US$) in Uruguay in 2013?
Your answer should be compact. -1.25e+1. What is the difference between the Imports (BoP, current US$) in Grenada in 2010 and the Imports (BoP, current US$) in Romania in 2013?
Your response must be concise. -7.68e+1. What is the difference between the Imports (BoP, current US$) in Grenada in 2010 and the Imports (BoP, current US$) in Uruguay in 2013?
Offer a very short reply. -1.45e+1. What is the difference between the Imports (BoP, current US$) in Romania in 2010 and the Imports (BoP, current US$) in Uruguay in 2013?
Keep it short and to the point. 4.84e+1. What is the difference between the Imports (BoP, current US$) of French Polynesia in 2011 and the Imports (BoP, current US$) of Grenada in 2012?
Your response must be concise. 1.94e+09. What is the difference between the Imports (BoP, current US$) of French Polynesia in 2011 and the Imports (BoP, current US$) of Romania in 2012?
Keep it short and to the point. -6.97e+1. What is the difference between the Imports (BoP, current US$) in French Polynesia in 2011 and the Imports (BoP, current US$) in Uruguay in 2012?
Provide a succinct answer. -1.24e+1. What is the difference between the Imports (BoP, current US$) of Grenada in 2011 and the Imports (BoP, current US$) of Romania in 2012?
Ensure brevity in your answer.  -7.16e+1. What is the difference between the Imports (BoP, current US$) in Grenada in 2011 and the Imports (BoP, current US$) in Uruguay in 2012?
Give a very brief answer. -1.43e+1. What is the difference between the Imports (BoP, current US$) of Romania in 2011 and the Imports (BoP, current US$) of Uruguay in 2012?
Your answer should be very brief. 6.31e+1. What is the difference between the Imports (BoP, current US$) of French Polynesia in 2011 and the Imports (BoP, current US$) of Grenada in 2013?
Make the answer very short. 1.91e+09. What is the difference between the Imports (BoP, current US$) of French Polynesia in 2011 and the Imports (BoP, current US$) of Romania in 2013?
Keep it short and to the point. -7.48e+1. What is the difference between the Imports (BoP, current US$) in French Polynesia in 2011 and the Imports (BoP, current US$) in Uruguay in 2013?
Give a very brief answer. -1.25e+1. What is the difference between the Imports (BoP, current US$) in Grenada in 2011 and the Imports (BoP, current US$) in Romania in 2013?
Make the answer very short. -7.68e+1. What is the difference between the Imports (BoP, current US$) in Grenada in 2011 and the Imports (BoP, current US$) in Uruguay in 2013?
Offer a very short reply. -1.45e+1. What is the difference between the Imports (BoP, current US$) of Romania in 2011 and the Imports (BoP, current US$) of Uruguay in 2013?
Your answer should be very brief. 6.30e+1. What is the difference between the Imports (BoP, current US$) in French Polynesia in 2012 and the Imports (BoP, current US$) in Grenada in 2013?
Your answer should be compact. 1.78e+09. What is the difference between the Imports (BoP, current US$) of French Polynesia in 2012 and the Imports (BoP, current US$) of Romania in 2013?
Your answer should be very brief. -7.50e+1. What is the difference between the Imports (BoP, current US$) of French Polynesia in 2012 and the Imports (BoP, current US$) of Uruguay in 2013?
Provide a succinct answer. -1.26e+1. What is the difference between the Imports (BoP, current US$) in Grenada in 2012 and the Imports (BoP, current US$) in Romania in 2013?
Your response must be concise. -7.68e+1. What is the difference between the Imports (BoP, current US$) of Grenada in 2012 and the Imports (BoP, current US$) of Uruguay in 2013?
Ensure brevity in your answer.  -1.45e+1. What is the difference between the Imports (BoP, current US$) of Romania in 2012 and the Imports (BoP, current US$) of Uruguay in 2013?
Provide a short and direct response. 5.72e+1. What is the average Imports (BoP, current US$) in French Polynesia per year?
Make the answer very short. 2.37e+09. What is the average Imports (BoP, current US$) of Grenada per year?
Ensure brevity in your answer.  4.06e+08. What is the average Imports (BoP, current US$) of Romania per year?
Offer a terse response. 6.77e+1. What is the average Imports (BoP, current US$) in Uruguay per year?
Offer a terse response. 1.04e+1. In the year 2006, what is the difference between the Imports (BoP, current US$) of French Polynesia and Imports (BoP, current US$) of Grenada?
Ensure brevity in your answer.  1.75e+09. In the year 2006, what is the difference between the Imports (BoP, current US$) in French Polynesia and Imports (BoP, current US$) in Romania?
Give a very brief answer. -4.27e+1. In the year 2006, what is the difference between the Imports (BoP, current US$) of French Polynesia and Imports (BoP, current US$) of Uruguay?
Ensure brevity in your answer.  -3.72e+09. In the year 2006, what is the difference between the Imports (BoP, current US$) in Grenada and Imports (BoP, current US$) in Romania?
Offer a terse response. -4.45e+1. In the year 2006, what is the difference between the Imports (BoP, current US$) in Grenada and Imports (BoP, current US$) in Uruguay?
Your answer should be compact. -5.47e+09. In the year 2006, what is the difference between the Imports (BoP, current US$) of Romania and Imports (BoP, current US$) of Uruguay?
Your answer should be compact. 3.90e+1. In the year 2007, what is the difference between the Imports (BoP, current US$) in French Polynesia and Imports (BoP, current US$) in Grenada?
Offer a very short reply. 2.00e+09. In the year 2007, what is the difference between the Imports (BoP, current US$) in French Polynesia and Imports (BoP, current US$) in Romania?
Your response must be concise. -6.48e+1. In the year 2007, what is the difference between the Imports (BoP, current US$) in French Polynesia and Imports (BoP, current US$) in Uruguay?
Your answer should be very brief. -4.34e+09. In the year 2007, what is the difference between the Imports (BoP, current US$) in Grenada and Imports (BoP, current US$) in Romania?
Provide a succinct answer. -6.68e+1. In the year 2007, what is the difference between the Imports (BoP, current US$) of Grenada and Imports (BoP, current US$) of Uruguay?
Offer a very short reply. -6.34e+09. In the year 2007, what is the difference between the Imports (BoP, current US$) in Romania and Imports (BoP, current US$) in Uruguay?
Ensure brevity in your answer.  6.04e+1. In the year 2008, what is the difference between the Imports (BoP, current US$) of French Polynesia and Imports (BoP, current US$) of Grenada?
Provide a succinct answer. 2.41e+09. In the year 2008, what is the difference between the Imports (BoP, current US$) in French Polynesia and Imports (BoP, current US$) in Romania?
Offer a terse response. -8.08e+1. In the year 2008, what is the difference between the Imports (BoP, current US$) in French Polynesia and Imports (BoP, current US$) in Uruguay?
Offer a very short reply. -7.47e+09. In the year 2008, what is the difference between the Imports (BoP, current US$) in Grenada and Imports (BoP, current US$) in Romania?
Offer a very short reply. -8.32e+1. In the year 2008, what is the difference between the Imports (BoP, current US$) in Grenada and Imports (BoP, current US$) in Uruguay?
Offer a very short reply. -9.88e+09. In the year 2008, what is the difference between the Imports (BoP, current US$) in Romania and Imports (BoP, current US$) in Uruguay?
Provide a short and direct response. 7.33e+1. In the year 2009, what is the difference between the Imports (BoP, current US$) in French Polynesia and Imports (BoP, current US$) in Grenada?
Ensure brevity in your answer.  2.02e+09. In the year 2009, what is the difference between the Imports (BoP, current US$) of French Polynesia and Imports (BoP, current US$) of Romania?
Keep it short and to the point. -5.31e+1. In the year 2009, what is the difference between the Imports (BoP, current US$) of French Polynesia and Imports (BoP, current US$) of Uruguay?
Make the answer very short. -5.81e+09. In the year 2009, what is the difference between the Imports (BoP, current US$) of Grenada and Imports (BoP, current US$) of Romania?
Provide a succinct answer. -5.52e+1. In the year 2009, what is the difference between the Imports (BoP, current US$) of Grenada and Imports (BoP, current US$) of Uruguay?
Give a very brief answer. -7.83e+09. In the year 2009, what is the difference between the Imports (BoP, current US$) of Romania and Imports (BoP, current US$) of Uruguay?
Keep it short and to the point. 4.73e+1. In the year 2010, what is the difference between the Imports (BoP, current US$) of French Polynesia and Imports (BoP, current US$) of Grenada?
Your response must be concise. 1.95e+09. In the year 2010, what is the difference between the Imports (BoP, current US$) in French Polynesia and Imports (BoP, current US$) in Romania?
Keep it short and to the point. -6.09e+1. In the year 2010, what is the difference between the Imports (BoP, current US$) in French Polynesia and Imports (BoP, current US$) in Uruguay?
Provide a succinct answer. -7.76e+09. In the year 2010, what is the difference between the Imports (BoP, current US$) in Grenada and Imports (BoP, current US$) in Romania?
Provide a short and direct response. -6.28e+1. In the year 2010, what is the difference between the Imports (BoP, current US$) of Grenada and Imports (BoP, current US$) of Uruguay?
Offer a very short reply. -9.71e+09. In the year 2010, what is the difference between the Imports (BoP, current US$) of Romania and Imports (BoP, current US$) of Uruguay?
Keep it short and to the point. 5.31e+1. In the year 2011, what is the difference between the Imports (BoP, current US$) in French Polynesia and Imports (BoP, current US$) in Grenada?
Provide a succinct answer. 1.94e+09. In the year 2011, what is the difference between the Imports (BoP, current US$) in French Polynesia and Imports (BoP, current US$) in Romania?
Your answer should be very brief. -7.55e+1. In the year 2011, what is the difference between the Imports (BoP, current US$) of French Polynesia and Imports (BoP, current US$) of Uruguay?
Provide a succinct answer. -1.04e+1. In the year 2011, what is the difference between the Imports (BoP, current US$) in Grenada and Imports (BoP, current US$) in Romania?
Give a very brief answer. -7.74e+1. In the year 2011, what is the difference between the Imports (BoP, current US$) of Grenada and Imports (BoP, current US$) of Uruguay?
Make the answer very short. -1.24e+1. In the year 2011, what is the difference between the Imports (BoP, current US$) in Romania and Imports (BoP, current US$) in Uruguay?
Your response must be concise. 6.51e+1. In the year 2012, what is the difference between the Imports (BoP, current US$) of French Polynesia and Imports (BoP, current US$) of Grenada?
Your answer should be compact. 1.81e+09. In the year 2012, what is the difference between the Imports (BoP, current US$) in French Polynesia and Imports (BoP, current US$) in Romania?
Ensure brevity in your answer.  -6.98e+1. In the year 2012, what is the difference between the Imports (BoP, current US$) of French Polynesia and Imports (BoP, current US$) of Uruguay?
Ensure brevity in your answer.  -1.25e+1. In the year 2012, what is the difference between the Imports (BoP, current US$) of Grenada and Imports (BoP, current US$) of Romania?
Your answer should be very brief. -7.16e+1. In the year 2012, what is the difference between the Imports (BoP, current US$) of Grenada and Imports (BoP, current US$) of Uruguay?
Offer a terse response. -1.43e+1. In the year 2012, what is the difference between the Imports (BoP, current US$) in Romania and Imports (BoP, current US$) in Uruguay?
Offer a terse response. 5.73e+1. In the year 2013, what is the difference between the Imports (BoP, current US$) in French Polynesia and Imports (BoP, current US$) in Grenada?
Your answer should be very brief. 1.86e+09. In the year 2013, what is the difference between the Imports (BoP, current US$) in French Polynesia and Imports (BoP, current US$) in Romania?
Offer a very short reply. -7.49e+1. In the year 2013, what is the difference between the Imports (BoP, current US$) of French Polynesia and Imports (BoP, current US$) of Uruguay?
Offer a terse response. -1.26e+1. In the year 2013, what is the difference between the Imports (BoP, current US$) of Grenada and Imports (BoP, current US$) of Romania?
Your response must be concise. -7.67e+1. In the year 2013, what is the difference between the Imports (BoP, current US$) in Grenada and Imports (BoP, current US$) in Uruguay?
Your response must be concise. -1.44e+1. In the year 2013, what is the difference between the Imports (BoP, current US$) of Romania and Imports (BoP, current US$) of Uruguay?
Offer a terse response. 6.23e+1. What is the ratio of the Imports (BoP, current US$) of French Polynesia in 2006 to that in 2007?
Provide a short and direct response. 0.89. What is the ratio of the Imports (BoP, current US$) of Grenada in 2006 to that in 2007?
Ensure brevity in your answer.  0.92. What is the ratio of the Imports (BoP, current US$) of Romania in 2006 to that in 2007?
Offer a very short reply. 0.67. What is the ratio of the Imports (BoP, current US$) in Uruguay in 2006 to that in 2007?
Provide a succinct answer. 0.87. What is the ratio of the Imports (BoP, current US$) in French Polynesia in 2006 to that in 2008?
Your response must be concise. 0.75. What is the ratio of the Imports (BoP, current US$) in Grenada in 2006 to that in 2008?
Make the answer very short. 0.89. What is the ratio of the Imports (BoP, current US$) in Romania in 2006 to that in 2008?
Keep it short and to the point. 0.54. What is the ratio of the Imports (BoP, current US$) of Uruguay in 2006 to that in 2008?
Your answer should be compact. 0.57. What is the ratio of the Imports (BoP, current US$) in French Polynesia in 2006 to that in 2009?
Give a very brief answer. 0.91. What is the ratio of the Imports (BoP, current US$) of Grenada in 2006 to that in 2009?
Your answer should be very brief. 1.11. What is the ratio of the Imports (BoP, current US$) of Romania in 2006 to that in 2009?
Provide a short and direct response. 0.81. What is the ratio of the Imports (BoP, current US$) in Uruguay in 2006 to that in 2009?
Make the answer very short. 0.72. What is the ratio of the Imports (BoP, current US$) in French Polynesia in 2006 to that in 2010?
Offer a very short reply. 0.93. What is the ratio of the Imports (BoP, current US$) in Grenada in 2006 to that in 2010?
Offer a very short reply. 1.06. What is the ratio of the Imports (BoP, current US$) in Romania in 2006 to that in 2010?
Provide a short and direct response. 0.71. What is the ratio of the Imports (BoP, current US$) in Uruguay in 2006 to that in 2010?
Keep it short and to the point. 0.58. What is the ratio of the Imports (BoP, current US$) in French Polynesia in 2006 to that in 2011?
Your answer should be very brief. 0.92. What is the ratio of the Imports (BoP, current US$) of Grenada in 2006 to that in 2011?
Your response must be concise. 1.02. What is the ratio of the Imports (BoP, current US$) of Romania in 2006 to that in 2011?
Make the answer very short. 0.58. What is the ratio of the Imports (BoP, current US$) in Uruguay in 2006 to that in 2011?
Offer a terse response. 0.46. What is the ratio of the Imports (BoP, current US$) of French Polynesia in 2006 to that in 2012?
Provide a short and direct response. 0.98. What is the ratio of the Imports (BoP, current US$) of Grenada in 2006 to that in 2012?
Offer a terse response. 1.02. What is the ratio of the Imports (BoP, current US$) in Romania in 2006 to that in 2012?
Keep it short and to the point. 0.62. What is the ratio of the Imports (BoP, current US$) in Uruguay in 2006 to that in 2012?
Ensure brevity in your answer.  0.4. What is the ratio of the Imports (BoP, current US$) in French Polynesia in 2006 to that in 2013?
Offer a terse response. 0.95. What is the ratio of the Imports (BoP, current US$) of Grenada in 2006 to that in 2013?
Keep it short and to the point. 0.95. What is the ratio of the Imports (BoP, current US$) of Romania in 2006 to that in 2013?
Offer a very short reply. 0.58. What is the ratio of the Imports (BoP, current US$) of Uruguay in 2006 to that in 2013?
Your answer should be compact. 0.4. What is the ratio of the Imports (BoP, current US$) in French Polynesia in 2007 to that in 2008?
Give a very brief answer. 0.85. What is the ratio of the Imports (BoP, current US$) in Grenada in 2007 to that in 2008?
Your answer should be compact. 0.97. What is the ratio of the Imports (BoP, current US$) of Romania in 2007 to that in 2008?
Ensure brevity in your answer.  0.8. What is the ratio of the Imports (BoP, current US$) of Uruguay in 2007 to that in 2008?
Your answer should be compact. 0.66. What is the ratio of the Imports (BoP, current US$) of French Polynesia in 2007 to that in 2009?
Provide a short and direct response. 1.02. What is the ratio of the Imports (BoP, current US$) of Grenada in 2007 to that in 2009?
Your answer should be very brief. 1.21. What is the ratio of the Imports (BoP, current US$) of Romania in 2007 to that in 2009?
Keep it short and to the point. 1.21. What is the ratio of the Imports (BoP, current US$) of Uruguay in 2007 to that in 2009?
Keep it short and to the point. 0.83. What is the ratio of the Imports (BoP, current US$) in French Polynesia in 2007 to that in 2010?
Your answer should be very brief. 1.04. What is the ratio of the Imports (BoP, current US$) of Grenada in 2007 to that in 2010?
Make the answer very short. 1.15. What is the ratio of the Imports (BoP, current US$) in Romania in 2007 to that in 2010?
Your answer should be compact. 1.06. What is the ratio of the Imports (BoP, current US$) of Uruguay in 2007 to that in 2010?
Provide a short and direct response. 0.67. What is the ratio of the Imports (BoP, current US$) in French Polynesia in 2007 to that in 2011?
Make the answer very short. 1.04. What is the ratio of the Imports (BoP, current US$) of Grenada in 2007 to that in 2011?
Offer a very short reply. 1.1. What is the ratio of the Imports (BoP, current US$) of Romania in 2007 to that in 2011?
Your answer should be compact. 0.86. What is the ratio of the Imports (BoP, current US$) in Uruguay in 2007 to that in 2011?
Your answer should be very brief. 0.53. What is the ratio of the Imports (BoP, current US$) of French Polynesia in 2007 to that in 2012?
Offer a very short reply. 1.1. What is the ratio of the Imports (BoP, current US$) in Grenada in 2007 to that in 2012?
Ensure brevity in your answer.  1.1. What is the ratio of the Imports (BoP, current US$) of Romania in 2007 to that in 2012?
Ensure brevity in your answer.  0.93. What is the ratio of the Imports (BoP, current US$) of Uruguay in 2007 to that in 2012?
Offer a terse response. 0.46. What is the ratio of the Imports (BoP, current US$) in French Polynesia in 2007 to that in 2013?
Your response must be concise. 1.07. What is the ratio of the Imports (BoP, current US$) in Grenada in 2007 to that in 2013?
Give a very brief answer. 1.03. What is the ratio of the Imports (BoP, current US$) in Romania in 2007 to that in 2013?
Your answer should be compact. 0.87. What is the ratio of the Imports (BoP, current US$) in Uruguay in 2007 to that in 2013?
Offer a terse response. 0.46. What is the ratio of the Imports (BoP, current US$) in French Polynesia in 2008 to that in 2009?
Keep it short and to the point. 1.21. What is the ratio of the Imports (BoP, current US$) of Grenada in 2008 to that in 2009?
Your answer should be compact. 1.25. What is the ratio of the Imports (BoP, current US$) of Romania in 2008 to that in 2009?
Provide a short and direct response. 1.51. What is the ratio of the Imports (BoP, current US$) in Uruguay in 2008 to that in 2009?
Keep it short and to the point. 1.26. What is the ratio of the Imports (BoP, current US$) of French Polynesia in 2008 to that in 2010?
Offer a very short reply. 1.23. What is the ratio of the Imports (BoP, current US$) of Grenada in 2008 to that in 2010?
Give a very brief answer. 1.19. What is the ratio of the Imports (BoP, current US$) in Romania in 2008 to that in 2010?
Your answer should be compact. 1.32. What is the ratio of the Imports (BoP, current US$) in Uruguay in 2008 to that in 2010?
Keep it short and to the point. 1.02. What is the ratio of the Imports (BoP, current US$) of French Polynesia in 2008 to that in 2011?
Offer a very short reply. 1.23. What is the ratio of the Imports (BoP, current US$) in Grenada in 2008 to that in 2011?
Give a very brief answer. 1.14. What is the ratio of the Imports (BoP, current US$) of Romania in 2008 to that in 2011?
Give a very brief answer. 1.07. What is the ratio of the Imports (BoP, current US$) of Uruguay in 2008 to that in 2011?
Offer a very short reply. 0.81. What is the ratio of the Imports (BoP, current US$) in French Polynesia in 2008 to that in 2012?
Offer a terse response. 1.3. What is the ratio of the Imports (BoP, current US$) in Grenada in 2008 to that in 2012?
Offer a very short reply. 1.14. What is the ratio of the Imports (BoP, current US$) of Romania in 2008 to that in 2012?
Your answer should be very brief. 1.16. What is the ratio of the Imports (BoP, current US$) of Uruguay in 2008 to that in 2012?
Provide a short and direct response. 0.7. What is the ratio of the Imports (BoP, current US$) in French Polynesia in 2008 to that in 2013?
Offer a terse response. 1.26. What is the ratio of the Imports (BoP, current US$) in Grenada in 2008 to that in 2013?
Make the answer very short. 1.07. What is the ratio of the Imports (BoP, current US$) in Romania in 2008 to that in 2013?
Keep it short and to the point. 1.08. What is the ratio of the Imports (BoP, current US$) in Uruguay in 2008 to that in 2013?
Your answer should be compact. 0.7. What is the ratio of the Imports (BoP, current US$) in French Polynesia in 2009 to that in 2010?
Ensure brevity in your answer.  1.02. What is the ratio of the Imports (BoP, current US$) of Grenada in 2009 to that in 2010?
Your answer should be compact. 0.95. What is the ratio of the Imports (BoP, current US$) of Romania in 2009 to that in 2010?
Give a very brief answer. 0.88. What is the ratio of the Imports (BoP, current US$) in Uruguay in 2009 to that in 2010?
Your response must be concise. 0.81. What is the ratio of the Imports (BoP, current US$) in Grenada in 2009 to that in 2011?
Make the answer very short. 0.91. What is the ratio of the Imports (BoP, current US$) of Romania in 2009 to that in 2011?
Keep it short and to the point. 0.71. What is the ratio of the Imports (BoP, current US$) of Uruguay in 2009 to that in 2011?
Your answer should be very brief. 0.64. What is the ratio of the Imports (BoP, current US$) of French Polynesia in 2009 to that in 2012?
Ensure brevity in your answer.  1.08. What is the ratio of the Imports (BoP, current US$) in Grenada in 2009 to that in 2012?
Your answer should be compact. 0.91. What is the ratio of the Imports (BoP, current US$) of Romania in 2009 to that in 2012?
Your answer should be very brief. 0.77. What is the ratio of the Imports (BoP, current US$) of Uruguay in 2009 to that in 2012?
Give a very brief answer. 0.56. What is the ratio of the Imports (BoP, current US$) of French Polynesia in 2009 to that in 2013?
Keep it short and to the point. 1.04. What is the ratio of the Imports (BoP, current US$) of Grenada in 2009 to that in 2013?
Give a very brief answer. 0.85. What is the ratio of the Imports (BoP, current US$) of Romania in 2009 to that in 2013?
Make the answer very short. 0.72. What is the ratio of the Imports (BoP, current US$) of Uruguay in 2009 to that in 2013?
Your response must be concise. 0.55. What is the ratio of the Imports (BoP, current US$) of French Polynesia in 2010 to that in 2011?
Offer a terse response. 1. What is the ratio of the Imports (BoP, current US$) of Grenada in 2010 to that in 2011?
Your response must be concise. 0.96. What is the ratio of the Imports (BoP, current US$) in Romania in 2010 to that in 2011?
Offer a terse response. 0.81. What is the ratio of the Imports (BoP, current US$) in Uruguay in 2010 to that in 2011?
Your response must be concise. 0.79. What is the ratio of the Imports (BoP, current US$) of French Polynesia in 2010 to that in 2012?
Provide a short and direct response. 1.06. What is the ratio of the Imports (BoP, current US$) in Grenada in 2010 to that in 2012?
Give a very brief answer. 0.96. What is the ratio of the Imports (BoP, current US$) of Romania in 2010 to that in 2012?
Make the answer very short. 0.88. What is the ratio of the Imports (BoP, current US$) of Uruguay in 2010 to that in 2012?
Your answer should be very brief. 0.69. What is the ratio of the Imports (BoP, current US$) of French Polynesia in 2010 to that in 2013?
Offer a very short reply. 1.02. What is the ratio of the Imports (BoP, current US$) in Grenada in 2010 to that in 2013?
Give a very brief answer. 0.9. What is the ratio of the Imports (BoP, current US$) in Romania in 2010 to that in 2013?
Offer a very short reply. 0.82. What is the ratio of the Imports (BoP, current US$) in Uruguay in 2010 to that in 2013?
Offer a terse response. 0.68. What is the ratio of the Imports (BoP, current US$) in French Polynesia in 2011 to that in 2012?
Your answer should be very brief. 1.06. What is the ratio of the Imports (BoP, current US$) of Grenada in 2011 to that in 2012?
Provide a succinct answer. 1. What is the ratio of the Imports (BoP, current US$) of Romania in 2011 to that in 2012?
Your answer should be very brief. 1.08. What is the ratio of the Imports (BoP, current US$) of Uruguay in 2011 to that in 2012?
Your response must be concise. 0.87. What is the ratio of the Imports (BoP, current US$) of French Polynesia in 2011 to that in 2013?
Offer a very short reply. 1.02. What is the ratio of the Imports (BoP, current US$) of Grenada in 2011 to that in 2013?
Your answer should be compact. 0.93. What is the ratio of the Imports (BoP, current US$) in Romania in 2011 to that in 2013?
Provide a succinct answer. 1.01. What is the ratio of the Imports (BoP, current US$) of Uruguay in 2011 to that in 2013?
Provide a succinct answer. 0.86. What is the ratio of the Imports (BoP, current US$) in French Polynesia in 2012 to that in 2013?
Make the answer very short. 0.97. What is the ratio of the Imports (BoP, current US$) of Grenada in 2012 to that in 2013?
Offer a terse response. 0.93. What is the ratio of the Imports (BoP, current US$) of Romania in 2012 to that in 2013?
Ensure brevity in your answer.  0.93. What is the difference between the highest and the second highest Imports (BoP, current US$) of French Polynesia?
Give a very brief answer. 4.33e+08. What is the difference between the highest and the second highest Imports (BoP, current US$) in Grenada?
Give a very brief answer. 1.53e+07. What is the difference between the highest and the second highest Imports (BoP, current US$) of Romania?
Ensure brevity in your answer.  5.84e+09. What is the difference between the highest and the second highest Imports (BoP, current US$) of Uruguay?
Your answer should be very brief. 1.60e+08. What is the difference between the highest and the lowest Imports (BoP, current US$) in French Polynesia?
Make the answer very short. 7.10e+08. What is the difference between the highest and the lowest Imports (BoP, current US$) in Grenada?
Offer a very short reply. 9.08e+07. What is the difference between the highest and the lowest Imports (BoP, current US$) of Romania?
Keep it short and to the point. 3.87e+1. What is the difference between the highest and the lowest Imports (BoP, current US$) of Uruguay?
Your answer should be very brief. 8.97e+09. 